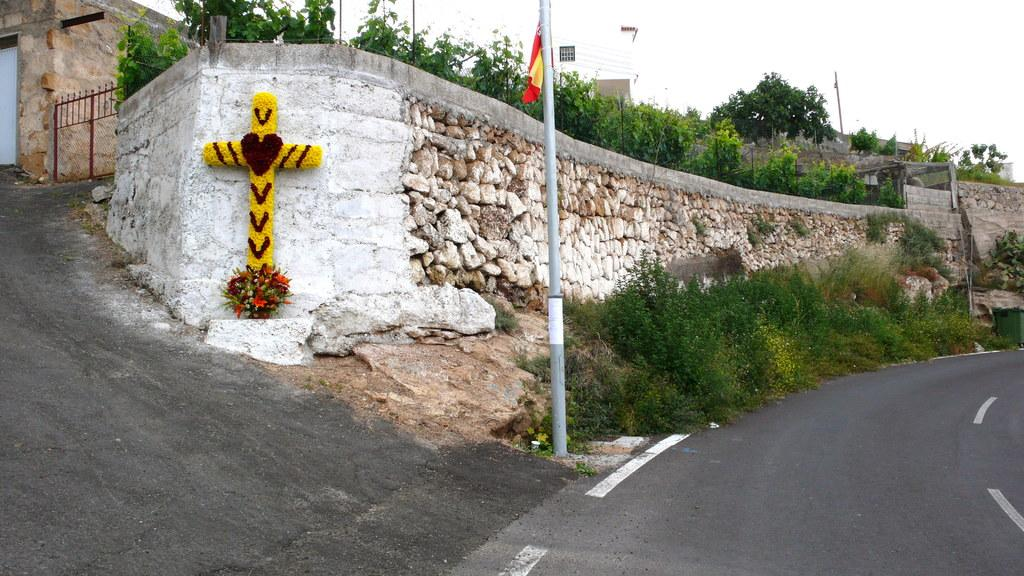What can be seen on the right side of the image? There is a road on the right side of the image. What type of natural elements are present in the image? There are plants, flowers, trees, and a stone wall in the image. What man-made structures can be seen in the image? There is a pole, a flag, a Christianity sign, a gate, and buildings in the background of the image. Are there any additional features in the image? Yes, there are wires and a flag in the image. How much is the payment for the turn in the image? There is no payment or turn present in the image; it features a road, plants, a pole, a flag, a Christianity sign, flowers, a stone wall, trees, wires, a gate, and buildings in the background. 